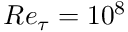Convert formula to latex. <formula><loc_0><loc_0><loc_500><loc_500>R e _ { \tau } = 1 0 ^ { 8 }</formula> 